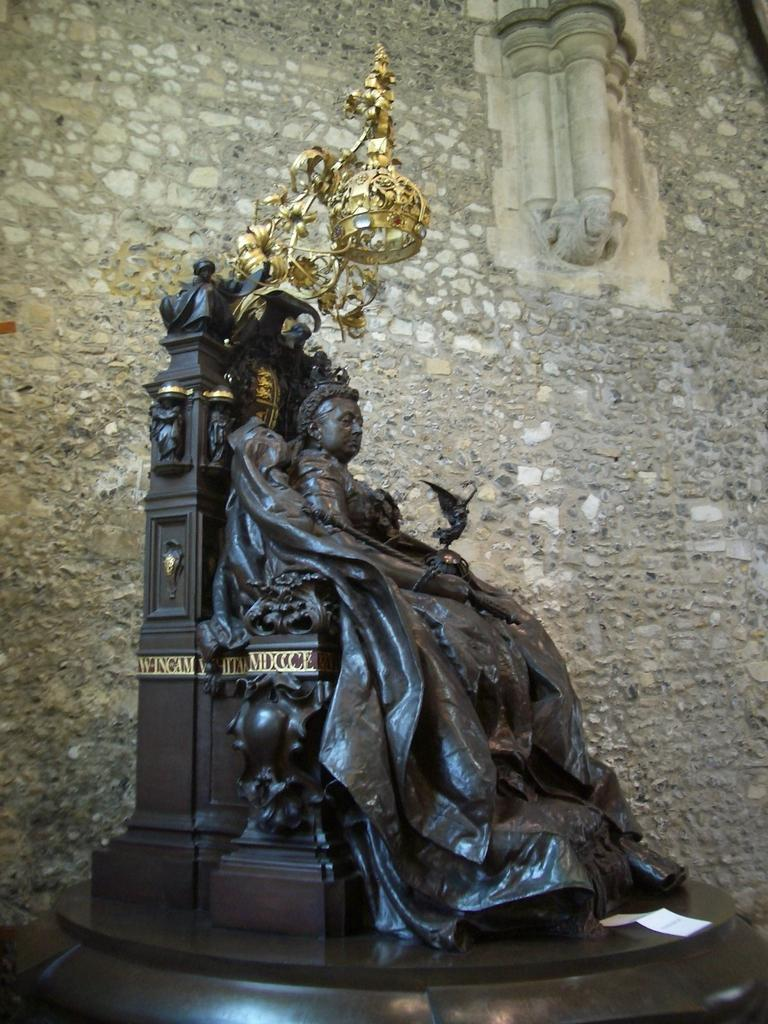What is the main subject in the image? There is an idol in the image. What other object can be seen in the image? There is a lamp in the image. What is visible in the background of the image? There is a wall in the background of the image. What type of vegetable is being served at the party in the image? There is no party or vegetable present in the image; it features an idol and a lamp with a wall in the background. How many chickens can be seen in the image? There are no chickens present in the image. 